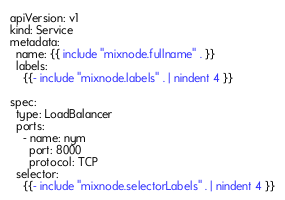<code> <loc_0><loc_0><loc_500><loc_500><_YAML_>apiVersion: v1
kind: Service
metadata:
  name: {{ include "mixnode.fullname" . }}
  labels:
    {{- include "mixnode.labels" . | nindent 4 }}

spec:
  type: LoadBalancer
  ports:
    - name: nym
      port: 8000
      protocol: TCP
  selector:
    {{- include "mixnode.selectorLabels" . | nindent 4 }}
</code> 